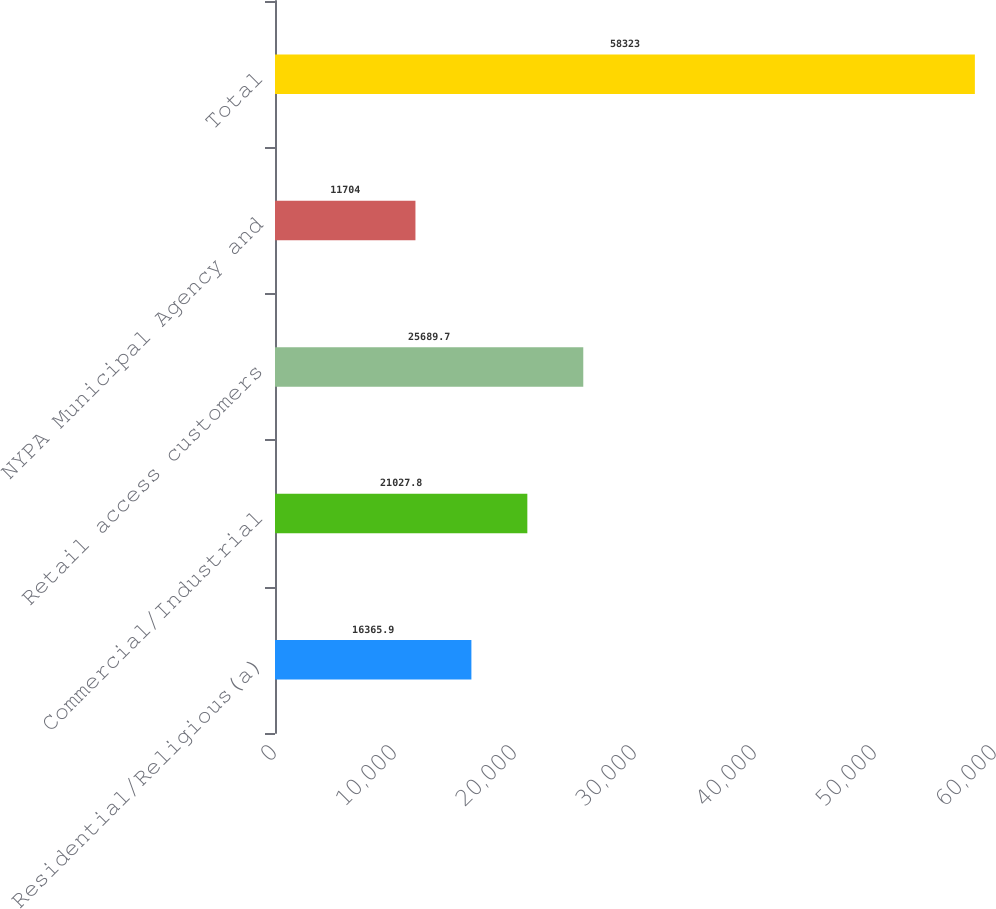Convert chart. <chart><loc_0><loc_0><loc_500><loc_500><bar_chart><fcel>Residential/Religious(a)<fcel>Commercial/Industrial<fcel>Retail access customers<fcel>NYPA Municipal Agency and<fcel>Total<nl><fcel>16365.9<fcel>21027.8<fcel>25689.7<fcel>11704<fcel>58323<nl></chart> 